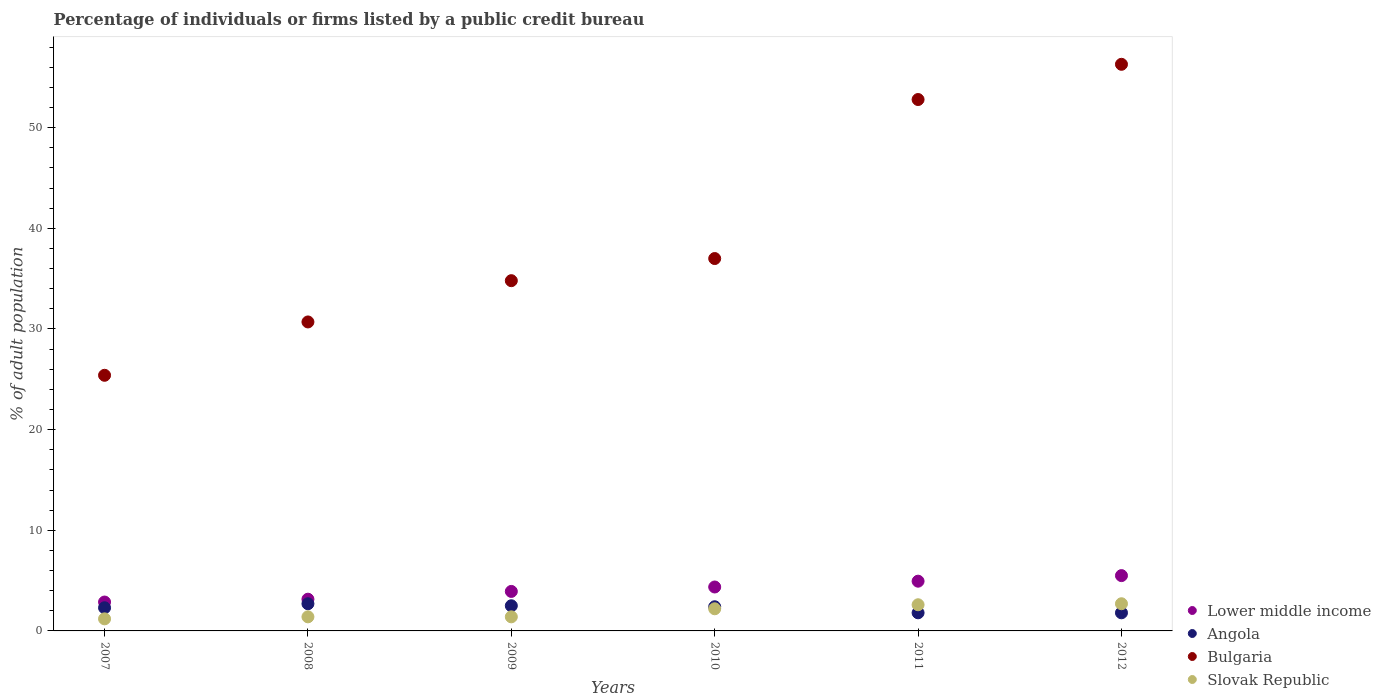What is the percentage of population listed by a public credit bureau in Bulgaria in 2012?
Provide a succinct answer. 56.3. Across all years, what is the minimum percentage of population listed by a public credit bureau in Bulgaria?
Provide a succinct answer. 25.4. In which year was the percentage of population listed by a public credit bureau in Lower middle income maximum?
Keep it short and to the point. 2012. What is the total percentage of population listed by a public credit bureau in Angola in the graph?
Your answer should be compact. 13.5. What is the difference between the percentage of population listed by a public credit bureau in Lower middle income in 2008 and that in 2009?
Provide a short and direct response. -0.77. What is the difference between the percentage of population listed by a public credit bureau in Slovak Republic in 2011 and the percentage of population listed by a public credit bureau in Bulgaria in 2009?
Your answer should be very brief. -32.2. What is the average percentage of population listed by a public credit bureau in Lower middle income per year?
Make the answer very short. 4.12. In the year 2010, what is the difference between the percentage of population listed by a public credit bureau in Lower middle income and percentage of population listed by a public credit bureau in Angola?
Keep it short and to the point. 1.96. What is the ratio of the percentage of population listed by a public credit bureau in Slovak Republic in 2009 to that in 2011?
Your answer should be compact. 0.54. Is the percentage of population listed by a public credit bureau in Slovak Republic in 2010 less than that in 2011?
Offer a very short reply. Yes. What is the difference between the highest and the second highest percentage of population listed by a public credit bureau in Angola?
Provide a short and direct response. 0.2. What is the difference between the highest and the lowest percentage of population listed by a public credit bureau in Slovak Republic?
Offer a very short reply. 1.5. In how many years, is the percentage of population listed by a public credit bureau in Lower middle income greater than the average percentage of population listed by a public credit bureau in Lower middle income taken over all years?
Provide a succinct answer. 3. Is the percentage of population listed by a public credit bureau in Angola strictly greater than the percentage of population listed by a public credit bureau in Bulgaria over the years?
Offer a very short reply. No. How many dotlines are there?
Ensure brevity in your answer.  4. How many years are there in the graph?
Offer a very short reply. 6. Are the values on the major ticks of Y-axis written in scientific E-notation?
Your response must be concise. No. How are the legend labels stacked?
Your answer should be very brief. Vertical. What is the title of the graph?
Make the answer very short. Percentage of individuals or firms listed by a public credit bureau. Does "Malawi" appear as one of the legend labels in the graph?
Your answer should be very brief. No. What is the label or title of the Y-axis?
Your answer should be very brief. % of adult population. What is the % of adult population in Lower middle income in 2007?
Give a very brief answer. 2.87. What is the % of adult population in Bulgaria in 2007?
Offer a terse response. 25.4. What is the % of adult population in Slovak Republic in 2007?
Keep it short and to the point. 1.2. What is the % of adult population in Lower middle income in 2008?
Keep it short and to the point. 3.15. What is the % of adult population of Bulgaria in 2008?
Offer a terse response. 30.7. What is the % of adult population of Slovak Republic in 2008?
Your response must be concise. 1.4. What is the % of adult population of Lower middle income in 2009?
Your answer should be very brief. 3.92. What is the % of adult population in Bulgaria in 2009?
Make the answer very short. 34.8. What is the % of adult population of Slovak Republic in 2009?
Your answer should be compact. 1.4. What is the % of adult population in Lower middle income in 2010?
Ensure brevity in your answer.  4.36. What is the % of adult population of Angola in 2010?
Keep it short and to the point. 2.4. What is the % of adult population of Lower middle income in 2011?
Offer a very short reply. 4.94. What is the % of adult population in Angola in 2011?
Your answer should be compact. 1.8. What is the % of adult population in Bulgaria in 2011?
Offer a very short reply. 52.8. What is the % of adult population in Slovak Republic in 2011?
Ensure brevity in your answer.  2.6. What is the % of adult population in Lower middle income in 2012?
Provide a short and direct response. 5.5. What is the % of adult population in Bulgaria in 2012?
Keep it short and to the point. 56.3. Across all years, what is the maximum % of adult population of Lower middle income?
Offer a very short reply. 5.5. Across all years, what is the maximum % of adult population in Bulgaria?
Give a very brief answer. 56.3. Across all years, what is the minimum % of adult population in Lower middle income?
Ensure brevity in your answer.  2.87. Across all years, what is the minimum % of adult population in Angola?
Ensure brevity in your answer.  1.8. Across all years, what is the minimum % of adult population in Bulgaria?
Provide a succinct answer. 25.4. What is the total % of adult population in Lower middle income in the graph?
Keep it short and to the point. 24.75. What is the total % of adult population of Bulgaria in the graph?
Provide a succinct answer. 237. What is the total % of adult population in Slovak Republic in the graph?
Give a very brief answer. 11.5. What is the difference between the % of adult population of Lower middle income in 2007 and that in 2008?
Keep it short and to the point. -0.28. What is the difference between the % of adult population of Angola in 2007 and that in 2008?
Your answer should be very brief. -0.4. What is the difference between the % of adult population of Bulgaria in 2007 and that in 2008?
Provide a short and direct response. -5.3. What is the difference between the % of adult population of Slovak Republic in 2007 and that in 2008?
Your response must be concise. -0.2. What is the difference between the % of adult population in Lower middle income in 2007 and that in 2009?
Make the answer very short. -1.05. What is the difference between the % of adult population in Slovak Republic in 2007 and that in 2009?
Provide a succinct answer. -0.2. What is the difference between the % of adult population of Lower middle income in 2007 and that in 2010?
Provide a short and direct response. -1.49. What is the difference between the % of adult population in Angola in 2007 and that in 2010?
Ensure brevity in your answer.  -0.1. What is the difference between the % of adult population in Bulgaria in 2007 and that in 2010?
Ensure brevity in your answer.  -11.6. What is the difference between the % of adult population of Slovak Republic in 2007 and that in 2010?
Your answer should be compact. -1. What is the difference between the % of adult population of Lower middle income in 2007 and that in 2011?
Your response must be concise. -2.07. What is the difference between the % of adult population in Angola in 2007 and that in 2011?
Ensure brevity in your answer.  0.5. What is the difference between the % of adult population in Bulgaria in 2007 and that in 2011?
Offer a terse response. -27.4. What is the difference between the % of adult population of Lower middle income in 2007 and that in 2012?
Provide a succinct answer. -2.63. What is the difference between the % of adult population in Bulgaria in 2007 and that in 2012?
Your answer should be compact. -30.9. What is the difference between the % of adult population of Lower middle income in 2008 and that in 2009?
Your answer should be compact. -0.77. What is the difference between the % of adult population in Lower middle income in 2008 and that in 2010?
Ensure brevity in your answer.  -1.21. What is the difference between the % of adult population of Angola in 2008 and that in 2010?
Offer a terse response. 0.3. What is the difference between the % of adult population in Bulgaria in 2008 and that in 2010?
Offer a very short reply. -6.3. What is the difference between the % of adult population in Slovak Republic in 2008 and that in 2010?
Make the answer very short. -0.8. What is the difference between the % of adult population of Lower middle income in 2008 and that in 2011?
Provide a succinct answer. -1.79. What is the difference between the % of adult population of Angola in 2008 and that in 2011?
Your answer should be compact. 0.9. What is the difference between the % of adult population in Bulgaria in 2008 and that in 2011?
Ensure brevity in your answer.  -22.1. What is the difference between the % of adult population of Lower middle income in 2008 and that in 2012?
Make the answer very short. -2.34. What is the difference between the % of adult population in Bulgaria in 2008 and that in 2012?
Provide a short and direct response. -25.6. What is the difference between the % of adult population in Lower middle income in 2009 and that in 2010?
Ensure brevity in your answer.  -0.44. What is the difference between the % of adult population of Angola in 2009 and that in 2010?
Your answer should be very brief. 0.1. What is the difference between the % of adult population in Slovak Republic in 2009 and that in 2010?
Give a very brief answer. -0.8. What is the difference between the % of adult population of Lower middle income in 2009 and that in 2011?
Give a very brief answer. -1.02. What is the difference between the % of adult population in Angola in 2009 and that in 2011?
Your response must be concise. 0.7. What is the difference between the % of adult population in Slovak Republic in 2009 and that in 2011?
Your answer should be very brief. -1.2. What is the difference between the % of adult population of Lower middle income in 2009 and that in 2012?
Keep it short and to the point. -1.57. What is the difference between the % of adult population of Angola in 2009 and that in 2012?
Your answer should be compact. 0.7. What is the difference between the % of adult population of Bulgaria in 2009 and that in 2012?
Make the answer very short. -21.5. What is the difference between the % of adult population in Slovak Republic in 2009 and that in 2012?
Ensure brevity in your answer.  -1.3. What is the difference between the % of adult population in Lower middle income in 2010 and that in 2011?
Your response must be concise. -0.58. What is the difference between the % of adult population of Bulgaria in 2010 and that in 2011?
Offer a terse response. -15.8. What is the difference between the % of adult population in Slovak Republic in 2010 and that in 2011?
Make the answer very short. -0.4. What is the difference between the % of adult population in Lower middle income in 2010 and that in 2012?
Offer a terse response. -1.13. What is the difference between the % of adult population of Bulgaria in 2010 and that in 2012?
Provide a short and direct response. -19.3. What is the difference between the % of adult population of Slovak Republic in 2010 and that in 2012?
Offer a very short reply. -0.5. What is the difference between the % of adult population in Lower middle income in 2011 and that in 2012?
Make the answer very short. -0.55. What is the difference between the % of adult population in Angola in 2011 and that in 2012?
Your response must be concise. 0. What is the difference between the % of adult population of Bulgaria in 2011 and that in 2012?
Provide a short and direct response. -3.5. What is the difference between the % of adult population in Lower middle income in 2007 and the % of adult population in Angola in 2008?
Your answer should be very brief. 0.17. What is the difference between the % of adult population in Lower middle income in 2007 and the % of adult population in Bulgaria in 2008?
Your response must be concise. -27.83. What is the difference between the % of adult population of Lower middle income in 2007 and the % of adult population of Slovak Republic in 2008?
Give a very brief answer. 1.47. What is the difference between the % of adult population of Angola in 2007 and the % of adult population of Bulgaria in 2008?
Your response must be concise. -28.4. What is the difference between the % of adult population in Angola in 2007 and the % of adult population in Slovak Republic in 2008?
Your answer should be very brief. 0.9. What is the difference between the % of adult population in Lower middle income in 2007 and the % of adult population in Angola in 2009?
Ensure brevity in your answer.  0.37. What is the difference between the % of adult population of Lower middle income in 2007 and the % of adult population of Bulgaria in 2009?
Ensure brevity in your answer.  -31.93. What is the difference between the % of adult population in Lower middle income in 2007 and the % of adult population in Slovak Republic in 2009?
Offer a very short reply. 1.47. What is the difference between the % of adult population in Angola in 2007 and the % of adult population in Bulgaria in 2009?
Your response must be concise. -32.5. What is the difference between the % of adult population in Angola in 2007 and the % of adult population in Slovak Republic in 2009?
Keep it short and to the point. 0.9. What is the difference between the % of adult population of Bulgaria in 2007 and the % of adult population of Slovak Republic in 2009?
Your answer should be compact. 24. What is the difference between the % of adult population of Lower middle income in 2007 and the % of adult population of Angola in 2010?
Make the answer very short. 0.47. What is the difference between the % of adult population in Lower middle income in 2007 and the % of adult population in Bulgaria in 2010?
Your response must be concise. -34.13. What is the difference between the % of adult population of Lower middle income in 2007 and the % of adult population of Slovak Republic in 2010?
Ensure brevity in your answer.  0.67. What is the difference between the % of adult population in Angola in 2007 and the % of adult population in Bulgaria in 2010?
Provide a short and direct response. -34.7. What is the difference between the % of adult population in Bulgaria in 2007 and the % of adult population in Slovak Republic in 2010?
Your response must be concise. 23.2. What is the difference between the % of adult population in Lower middle income in 2007 and the % of adult population in Angola in 2011?
Your answer should be compact. 1.07. What is the difference between the % of adult population of Lower middle income in 2007 and the % of adult population of Bulgaria in 2011?
Provide a short and direct response. -49.93. What is the difference between the % of adult population in Lower middle income in 2007 and the % of adult population in Slovak Republic in 2011?
Offer a terse response. 0.27. What is the difference between the % of adult population in Angola in 2007 and the % of adult population in Bulgaria in 2011?
Your response must be concise. -50.5. What is the difference between the % of adult population in Angola in 2007 and the % of adult population in Slovak Republic in 2011?
Your answer should be compact. -0.3. What is the difference between the % of adult population of Bulgaria in 2007 and the % of adult population of Slovak Republic in 2011?
Offer a terse response. 22.8. What is the difference between the % of adult population in Lower middle income in 2007 and the % of adult population in Angola in 2012?
Offer a very short reply. 1.07. What is the difference between the % of adult population in Lower middle income in 2007 and the % of adult population in Bulgaria in 2012?
Offer a terse response. -53.43. What is the difference between the % of adult population in Lower middle income in 2007 and the % of adult population in Slovak Republic in 2012?
Provide a succinct answer. 0.17. What is the difference between the % of adult population in Angola in 2007 and the % of adult population in Bulgaria in 2012?
Provide a short and direct response. -54. What is the difference between the % of adult population in Angola in 2007 and the % of adult population in Slovak Republic in 2012?
Offer a terse response. -0.4. What is the difference between the % of adult population in Bulgaria in 2007 and the % of adult population in Slovak Republic in 2012?
Ensure brevity in your answer.  22.7. What is the difference between the % of adult population in Lower middle income in 2008 and the % of adult population in Angola in 2009?
Your answer should be compact. 0.65. What is the difference between the % of adult population of Lower middle income in 2008 and the % of adult population of Bulgaria in 2009?
Your response must be concise. -31.65. What is the difference between the % of adult population of Lower middle income in 2008 and the % of adult population of Slovak Republic in 2009?
Provide a succinct answer. 1.75. What is the difference between the % of adult population in Angola in 2008 and the % of adult population in Bulgaria in 2009?
Make the answer very short. -32.1. What is the difference between the % of adult population of Angola in 2008 and the % of adult population of Slovak Republic in 2009?
Your answer should be very brief. 1.3. What is the difference between the % of adult population in Bulgaria in 2008 and the % of adult population in Slovak Republic in 2009?
Make the answer very short. 29.3. What is the difference between the % of adult population in Lower middle income in 2008 and the % of adult population in Angola in 2010?
Provide a succinct answer. 0.75. What is the difference between the % of adult population of Lower middle income in 2008 and the % of adult population of Bulgaria in 2010?
Your answer should be compact. -33.85. What is the difference between the % of adult population of Lower middle income in 2008 and the % of adult population of Slovak Republic in 2010?
Offer a terse response. 0.95. What is the difference between the % of adult population in Angola in 2008 and the % of adult population in Bulgaria in 2010?
Offer a terse response. -34.3. What is the difference between the % of adult population in Lower middle income in 2008 and the % of adult population in Angola in 2011?
Your response must be concise. 1.35. What is the difference between the % of adult population of Lower middle income in 2008 and the % of adult population of Bulgaria in 2011?
Make the answer very short. -49.65. What is the difference between the % of adult population in Lower middle income in 2008 and the % of adult population in Slovak Republic in 2011?
Offer a very short reply. 0.55. What is the difference between the % of adult population of Angola in 2008 and the % of adult population of Bulgaria in 2011?
Offer a very short reply. -50.1. What is the difference between the % of adult population in Angola in 2008 and the % of adult population in Slovak Republic in 2011?
Offer a terse response. 0.1. What is the difference between the % of adult population in Bulgaria in 2008 and the % of adult population in Slovak Republic in 2011?
Your answer should be very brief. 28.1. What is the difference between the % of adult population of Lower middle income in 2008 and the % of adult population of Angola in 2012?
Your answer should be very brief. 1.35. What is the difference between the % of adult population in Lower middle income in 2008 and the % of adult population in Bulgaria in 2012?
Keep it short and to the point. -53.15. What is the difference between the % of adult population in Lower middle income in 2008 and the % of adult population in Slovak Republic in 2012?
Provide a short and direct response. 0.45. What is the difference between the % of adult population of Angola in 2008 and the % of adult population of Bulgaria in 2012?
Your answer should be very brief. -53.6. What is the difference between the % of adult population of Angola in 2008 and the % of adult population of Slovak Republic in 2012?
Provide a short and direct response. 0. What is the difference between the % of adult population in Bulgaria in 2008 and the % of adult population in Slovak Republic in 2012?
Make the answer very short. 28. What is the difference between the % of adult population of Lower middle income in 2009 and the % of adult population of Angola in 2010?
Provide a succinct answer. 1.52. What is the difference between the % of adult population in Lower middle income in 2009 and the % of adult population in Bulgaria in 2010?
Provide a short and direct response. -33.08. What is the difference between the % of adult population of Lower middle income in 2009 and the % of adult population of Slovak Republic in 2010?
Make the answer very short. 1.72. What is the difference between the % of adult population of Angola in 2009 and the % of adult population of Bulgaria in 2010?
Your answer should be compact. -34.5. What is the difference between the % of adult population of Bulgaria in 2009 and the % of adult population of Slovak Republic in 2010?
Your answer should be very brief. 32.6. What is the difference between the % of adult population in Lower middle income in 2009 and the % of adult population in Angola in 2011?
Your response must be concise. 2.12. What is the difference between the % of adult population of Lower middle income in 2009 and the % of adult population of Bulgaria in 2011?
Give a very brief answer. -48.88. What is the difference between the % of adult population of Lower middle income in 2009 and the % of adult population of Slovak Republic in 2011?
Your response must be concise. 1.32. What is the difference between the % of adult population of Angola in 2009 and the % of adult population of Bulgaria in 2011?
Your answer should be very brief. -50.3. What is the difference between the % of adult population in Bulgaria in 2009 and the % of adult population in Slovak Republic in 2011?
Offer a very short reply. 32.2. What is the difference between the % of adult population in Lower middle income in 2009 and the % of adult population in Angola in 2012?
Keep it short and to the point. 2.12. What is the difference between the % of adult population of Lower middle income in 2009 and the % of adult population of Bulgaria in 2012?
Offer a terse response. -52.38. What is the difference between the % of adult population of Lower middle income in 2009 and the % of adult population of Slovak Republic in 2012?
Your answer should be very brief. 1.22. What is the difference between the % of adult population of Angola in 2009 and the % of adult population of Bulgaria in 2012?
Give a very brief answer. -53.8. What is the difference between the % of adult population in Bulgaria in 2009 and the % of adult population in Slovak Republic in 2012?
Offer a very short reply. 32.1. What is the difference between the % of adult population in Lower middle income in 2010 and the % of adult population in Angola in 2011?
Offer a very short reply. 2.56. What is the difference between the % of adult population of Lower middle income in 2010 and the % of adult population of Bulgaria in 2011?
Your answer should be compact. -48.44. What is the difference between the % of adult population of Lower middle income in 2010 and the % of adult population of Slovak Republic in 2011?
Offer a terse response. 1.76. What is the difference between the % of adult population in Angola in 2010 and the % of adult population in Bulgaria in 2011?
Offer a terse response. -50.4. What is the difference between the % of adult population in Bulgaria in 2010 and the % of adult population in Slovak Republic in 2011?
Make the answer very short. 34.4. What is the difference between the % of adult population of Lower middle income in 2010 and the % of adult population of Angola in 2012?
Offer a terse response. 2.56. What is the difference between the % of adult population in Lower middle income in 2010 and the % of adult population in Bulgaria in 2012?
Your response must be concise. -51.94. What is the difference between the % of adult population of Lower middle income in 2010 and the % of adult population of Slovak Republic in 2012?
Ensure brevity in your answer.  1.66. What is the difference between the % of adult population in Angola in 2010 and the % of adult population in Bulgaria in 2012?
Make the answer very short. -53.9. What is the difference between the % of adult population of Angola in 2010 and the % of adult population of Slovak Republic in 2012?
Give a very brief answer. -0.3. What is the difference between the % of adult population of Bulgaria in 2010 and the % of adult population of Slovak Republic in 2012?
Your answer should be very brief. 34.3. What is the difference between the % of adult population in Lower middle income in 2011 and the % of adult population in Angola in 2012?
Ensure brevity in your answer.  3.14. What is the difference between the % of adult population in Lower middle income in 2011 and the % of adult population in Bulgaria in 2012?
Give a very brief answer. -51.36. What is the difference between the % of adult population in Lower middle income in 2011 and the % of adult population in Slovak Republic in 2012?
Ensure brevity in your answer.  2.24. What is the difference between the % of adult population of Angola in 2011 and the % of adult population of Bulgaria in 2012?
Your answer should be compact. -54.5. What is the difference between the % of adult population of Angola in 2011 and the % of adult population of Slovak Republic in 2012?
Ensure brevity in your answer.  -0.9. What is the difference between the % of adult population in Bulgaria in 2011 and the % of adult population in Slovak Republic in 2012?
Ensure brevity in your answer.  50.1. What is the average % of adult population of Lower middle income per year?
Make the answer very short. 4.12. What is the average % of adult population in Angola per year?
Ensure brevity in your answer.  2.25. What is the average % of adult population of Bulgaria per year?
Your answer should be very brief. 39.5. What is the average % of adult population in Slovak Republic per year?
Your answer should be very brief. 1.92. In the year 2007, what is the difference between the % of adult population in Lower middle income and % of adult population in Angola?
Make the answer very short. 0.57. In the year 2007, what is the difference between the % of adult population in Lower middle income and % of adult population in Bulgaria?
Provide a short and direct response. -22.53. In the year 2007, what is the difference between the % of adult population of Lower middle income and % of adult population of Slovak Republic?
Keep it short and to the point. 1.67. In the year 2007, what is the difference between the % of adult population in Angola and % of adult population in Bulgaria?
Provide a short and direct response. -23.1. In the year 2007, what is the difference between the % of adult population of Angola and % of adult population of Slovak Republic?
Provide a short and direct response. 1.1. In the year 2007, what is the difference between the % of adult population of Bulgaria and % of adult population of Slovak Republic?
Your answer should be compact. 24.2. In the year 2008, what is the difference between the % of adult population of Lower middle income and % of adult population of Angola?
Your response must be concise. 0.45. In the year 2008, what is the difference between the % of adult population in Lower middle income and % of adult population in Bulgaria?
Give a very brief answer. -27.55. In the year 2008, what is the difference between the % of adult population in Lower middle income and % of adult population in Slovak Republic?
Give a very brief answer. 1.75. In the year 2008, what is the difference between the % of adult population in Angola and % of adult population in Bulgaria?
Your answer should be very brief. -28. In the year 2008, what is the difference between the % of adult population of Angola and % of adult population of Slovak Republic?
Ensure brevity in your answer.  1.3. In the year 2008, what is the difference between the % of adult population in Bulgaria and % of adult population in Slovak Republic?
Offer a very short reply. 29.3. In the year 2009, what is the difference between the % of adult population of Lower middle income and % of adult population of Angola?
Your response must be concise. 1.42. In the year 2009, what is the difference between the % of adult population in Lower middle income and % of adult population in Bulgaria?
Give a very brief answer. -30.88. In the year 2009, what is the difference between the % of adult population in Lower middle income and % of adult population in Slovak Republic?
Provide a short and direct response. 2.52. In the year 2009, what is the difference between the % of adult population of Angola and % of adult population of Bulgaria?
Provide a succinct answer. -32.3. In the year 2009, what is the difference between the % of adult population of Angola and % of adult population of Slovak Republic?
Ensure brevity in your answer.  1.1. In the year 2009, what is the difference between the % of adult population of Bulgaria and % of adult population of Slovak Republic?
Your answer should be compact. 33.4. In the year 2010, what is the difference between the % of adult population of Lower middle income and % of adult population of Angola?
Provide a succinct answer. 1.96. In the year 2010, what is the difference between the % of adult population in Lower middle income and % of adult population in Bulgaria?
Provide a succinct answer. -32.64. In the year 2010, what is the difference between the % of adult population of Lower middle income and % of adult population of Slovak Republic?
Offer a very short reply. 2.16. In the year 2010, what is the difference between the % of adult population in Angola and % of adult population in Bulgaria?
Your answer should be very brief. -34.6. In the year 2010, what is the difference between the % of adult population in Angola and % of adult population in Slovak Republic?
Offer a terse response. 0.2. In the year 2010, what is the difference between the % of adult population of Bulgaria and % of adult population of Slovak Republic?
Provide a succinct answer. 34.8. In the year 2011, what is the difference between the % of adult population in Lower middle income and % of adult population in Angola?
Make the answer very short. 3.14. In the year 2011, what is the difference between the % of adult population in Lower middle income and % of adult population in Bulgaria?
Provide a short and direct response. -47.86. In the year 2011, what is the difference between the % of adult population of Lower middle income and % of adult population of Slovak Republic?
Offer a very short reply. 2.34. In the year 2011, what is the difference between the % of adult population of Angola and % of adult population of Bulgaria?
Provide a succinct answer. -51. In the year 2011, what is the difference between the % of adult population of Bulgaria and % of adult population of Slovak Republic?
Make the answer very short. 50.2. In the year 2012, what is the difference between the % of adult population of Lower middle income and % of adult population of Angola?
Provide a short and direct response. 3.7. In the year 2012, what is the difference between the % of adult population of Lower middle income and % of adult population of Bulgaria?
Your response must be concise. -50.8. In the year 2012, what is the difference between the % of adult population of Lower middle income and % of adult population of Slovak Republic?
Your response must be concise. 2.8. In the year 2012, what is the difference between the % of adult population in Angola and % of adult population in Bulgaria?
Ensure brevity in your answer.  -54.5. In the year 2012, what is the difference between the % of adult population of Bulgaria and % of adult population of Slovak Republic?
Your response must be concise. 53.6. What is the ratio of the % of adult population in Lower middle income in 2007 to that in 2008?
Provide a succinct answer. 0.91. What is the ratio of the % of adult population of Angola in 2007 to that in 2008?
Ensure brevity in your answer.  0.85. What is the ratio of the % of adult population in Bulgaria in 2007 to that in 2008?
Provide a short and direct response. 0.83. What is the ratio of the % of adult population of Lower middle income in 2007 to that in 2009?
Your answer should be very brief. 0.73. What is the ratio of the % of adult population of Angola in 2007 to that in 2009?
Ensure brevity in your answer.  0.92. What is the ratio of the % of adult population of Bulgaria in 2007 to that in 2009?
Give a very brief answer. 0.73. What is the ratio of the % of adult population in Slovak Republic in 2007 to that in 2009?
Provide a short and direct response. 0.86. What is the ratio of the % of adult population in Lower middle income in 2007 to that in 2010?
Provide a succinct answer. 0.66. What is the ratio of the % of adult population of Angola in 2007 to that in 2010?
Make the answer very short. 0.96. What is the ratio of the % of adult population in Bulgaria in 2007 to that in 2010?
Make the answer very short. 0.69. What is the ratio of the % of adult population of Slovak Republic in 2007 to that in 2010?
Offer a terse response. 0.55. What is the ratio of the % of adult population in Lower middle income in 2007 to that in 2011?
Provide a succinct answer. 0.58. What is the ratio of the % of adult population in Angola in 2007 to that in 2011?
Make the answer very short. 1.28. What is the ratio of the % of adult population in Bulgaria in 2007 to that in 2011?
Provide a short and direct response. 0.48. What is the ratio of the % of adult population in Slovak Republic in 2007 to that in 2011?
Your answer should be compact. 0.46. What is the ratio of the % of adult population in Lower middle income in 2007 to that in 2012?
Your answer should be very brief. 0.52. What is the ratio of the % of adult population in Angola in 2007 to that in 2012?
Your response must be concise. 1.28. What is the ratio of the % of adult population in Bulgaria in 2007 to that in 2012?
Ensure brevity in your answer.  0.45. What is the ratio of the % of adult population of Slovak Republic in 2007 to that in 2012?
Offer a terse response. 0.44. What is the ratio of the % of adult population of Lower middle income in 2008 to that in 2009?
Ensure brevity in your answer.  0.8. What is the ratio of the % of adult population of Bulgaria in 2008 to that in 2009?
Keep it short and to the point. 0.88. What is the ratio of the % of adult population in Lower middle income in 2008 to that in 2010?
Make the answer very short. 0.72. What is the ratio of the % of adult population in Angola in 2008 to that in 2010?
Provide a short and direct response. 1.12. What is the ratio of the % of adult population of Bulgaria in 2008 to that in 2010?
Your response must be concise. 0.83. What is the ratio of the % of adult population in Slovak Republic in 2008 to that in 2010?
Provide a succinct answer. 0.64. What is the ratio of the % of adult population of Lower middle income in 2008 to that in 2011?
Your answer should be very brief. 0.64. What is the ratio of the % of adult population of Angola in 2008 to that in 2011?
Make the answer very short. 1.5. What is the ratio of the % of adult population in Bulgaria in 2008 to that in 2011?
Your answer should be compact. 0.58. What is the ratio of the % of adult population in Slovak Republic in 2008 to that in 2011?
Keep it short and to the point. 0.54. What is the ratio of the % of adult population of Lower middle income in 2008 to that in 2012?
Your answer should be compact. 0.57. What is the ratio of the % of adult population in Angola in 2008 to that in 2012?
Offer a terse response. 1.5. What is the ratio of the % of adult population in Bulgaria in 2008 to that in 2012?
Offer a very short reply. 0.55. What is the ratio of the % of adult population of Slovak Republic in 2008 to that in 2012?
Your answer should be compact. 0.52. What is the ratio of the % of adult population in Lower middle income in 2009 to that in 2010?
Keep it short and to the point. 0.9. What is the ratio of the % of adult population of Angola in 2009 to that in 2010?
Give a very brief answer. 1.04. What is the ratio of the % of adult population in Bulgaria in 2009 to that in 2010?
Keep it short and to the point. 0.94. What is the ratio of the % of adult population of Slovak Republic in 2009 to that in 2010?
Offer a very short reply. 0.64. What is the ratio of the % of adult population of Lower middle income in 2009 to that in 2011?
Provide a short and direct response. 0.79. What is the ratio of the % of adult population of Angola in 2009 to that in 2011?
Give a very brief answer. 1.39. What is the ratio of the % of adult population in Bulgaria in 2009 to that in 2011?
Your response must be concise. 0.66. What is the ratio of the % of adult population of Slovak Republic in 2009 to that in 2011?
Ensure brevity in your answer.  0.54. What is the ratio of the % of adult population of Lower middle income in 2009 to that in 2012?
Give a very brief answer. 0.71. What is the ratio of the % of adult population of Angola in 2009 to that in 2012?
Offer a terse response. 1.39. What is the ratio of the % of adult population of Bulgaria in 2009 to that in 2012?
Provide a succinct answer. 0.62. What is the ratio of the % of adult population of Slovak Republic in 2009 to that in 2012?
Provide a succinct answer. 0.52. What is the ratio of the % of adult population of Lower middle income in 2010 to that in 2011?
Ensure brevity in your answer.  0.88. What is the ratio of the % of adult population of Bulgaria in 2010 to that in 2011?
Ensure brevity in your answer.  0.7. What is the ratio of the % of adult population in Slovak Republic in 2010 to that in 2011?
Your response must be concise. 0.85. What is the ratio of the % of adult population in Lower middle income in 2010 to that in 2012?
Your response must be concise. 0.79. What is the ratio of the % of adult population of Bulgaria in 2010 to that in 2012?
Offer a terse response. 0.66. What is the ratio of the % of adult population of Slovak Republic in 2010 to that in 2012?
Give a very brief answer. 0.81. What is the ratio of the % of adult population of Lower middle income in 2011 to that in 2012?
Your answer should be compact. 0.9. What is the ratio of the % of adult population of Angola in 2011 to that in 2012?
Give a very brief answer. 1. What is the ratio of the % of adult population of Bulgaria in 2011 to that in 2012?
Keep it short and to the point. 0.94. What is the difference between the highest and the second highest % of adult population in Lower middle income?
Provide a succinct answer. 0.55. What is the difference between the highest and the lowest % of adult population of Lower middle income?
Give a very brief answer. 2.63. What is the difference between the highest and the lowest % of adult population of Bulgaria?
Offer a very short reply. 30.9. What is the difference between the highest and the lowest % of adult population of Slovak Republic?
Your response must be concise. 1.5. 